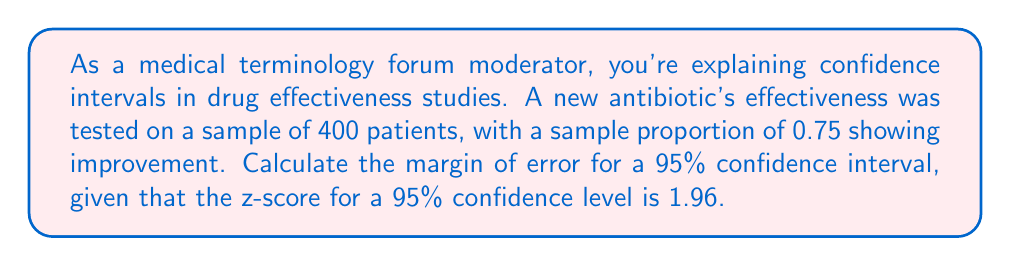Could you help me with this problem? Let's approach this step-by-step:

1) The formula for the margin of error (ME) in a confidence interval for a proportion is:

   $$ ME = z \sqrt{\frac{p(1-p)}{n}} $$

   Where:
   $z$ = z-score for the confidence level
   $p$ = sample proportion
   $n$ = sample size

2) We're given:
   $z = 1.96$ (for 95% confidence level)
   $p = 0.75$ (75% showed improvement)
   $n = 400$ (sample size)

3) Let's substitute these values into the formula:

   $$ ME = 1.96 \sqrt{\frac{0.75(1-0.75)}{400}} $$

4) Simplify inside the square root:

   $$ ME = 1.96 \sqrt{\frac{0.75(0.25)}{400}} = 1.96 \sqrt{\frac{0.1875}{400}} $$

5) Calculate:

   $$ ME = 1.96 \sqrt{0.00046875} \approx 1.96 * 0.02165 \approx 0.0424 $$

6) Round to 4 decimal places:

   $$ ME \approx 0.0424 $$

This means the margin of error is approximately 0.0424 or 4.24%.
Answer: 0.0424 